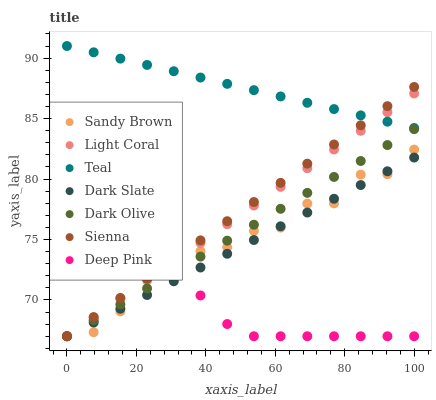Does Deep Pink have the minimum area under the curve?
Answer yes or no. Yes. Does Teal have the maximum area under the curve?
Answer yes or no. Yes. Does Dark Olive have the minimum area under the curve?
Answer yes or no. No. Does Dark Olive have the maximum area under the curve?
Answer yes or no. No. Is Dark Slate the smoothest?
Answer yes or no. Yes. Is Sandy Brown the roughest?
Answer yes or no. Yes. Is Deep Pink the smoothest?
Answer yes or no. No. Is Deep Pink the roughest?
Answer yes or no. No. Does Sienna have the lowest value?
Answer yes or no. Yes. Does Teal have the lowest value?
Answer yes or no. No. Does Teal have the highest value?
Answer yes or no. Yes. Does Dark Olive have the highest value?
Answer yes or no. No. Is Dark Slate less than Teal?
Answer yes or no. Yes. Is Teal greater than Deep Pink?
Answer yes or no. Yes. Does Light Coral intersect Dark Slate?
Answer yes or no. Yes. Is Light Coral less than Dark Slate?
Answer yes or no. No. Is Light Coral greater than Dark Slate?
Answer yes or no. No. Does Dark Slate intersect Teal?
Answer yes or no. No. 